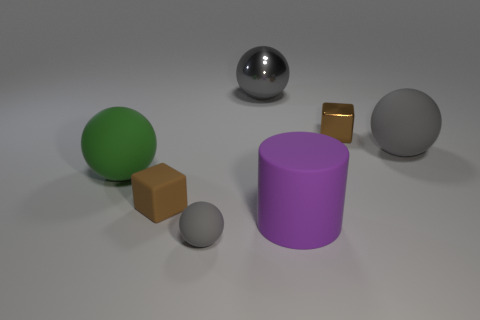Is the small brown object that is on the right side of the gray metal object made of the same material as the ball in front of the brown matte thing?
Offer a terse response. No. There is another tiny thing that is the same shape as the small metal object; what is its material?
Offer a very short reply. Rubber. Are there any other things that have the same size as the cylinder?
Make the answer very short. Yes. Is the shape of the tiny brown matte object that is left of the purple thing the same as the big rubber thing that is on the left side of the small sphere?
Offer a very short reply. No. Is the number of brown things that are to the right of the big rubber cylinder less than the number of large objects behind the tiny shiny cube?
Your response must be concise. No. How many other objects are the same shape as the tiny brown rubber object?
Offer a very short reply. 1. What is the shape of the green object that is the same material as the small gray thing?
Provide a succinct answer. Sphere. There is a rubber object that is both behind the tiny brown matte object and left of the tiny matte ball; what color is it?
Provide a succinct answer. Green. Is the tiny block that is on the left side of the cylinder made of the same material as the large green ball?
Offer a very short reply. Yes. Are there fewer brown metal blocks that are left of the green thing than green shiny things?
Provide a succinct answer. No. 